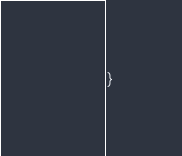Convert code to text. <code><loc_0><loc_0><loc_500><loc_500><_TypeScript_>}
</code> 